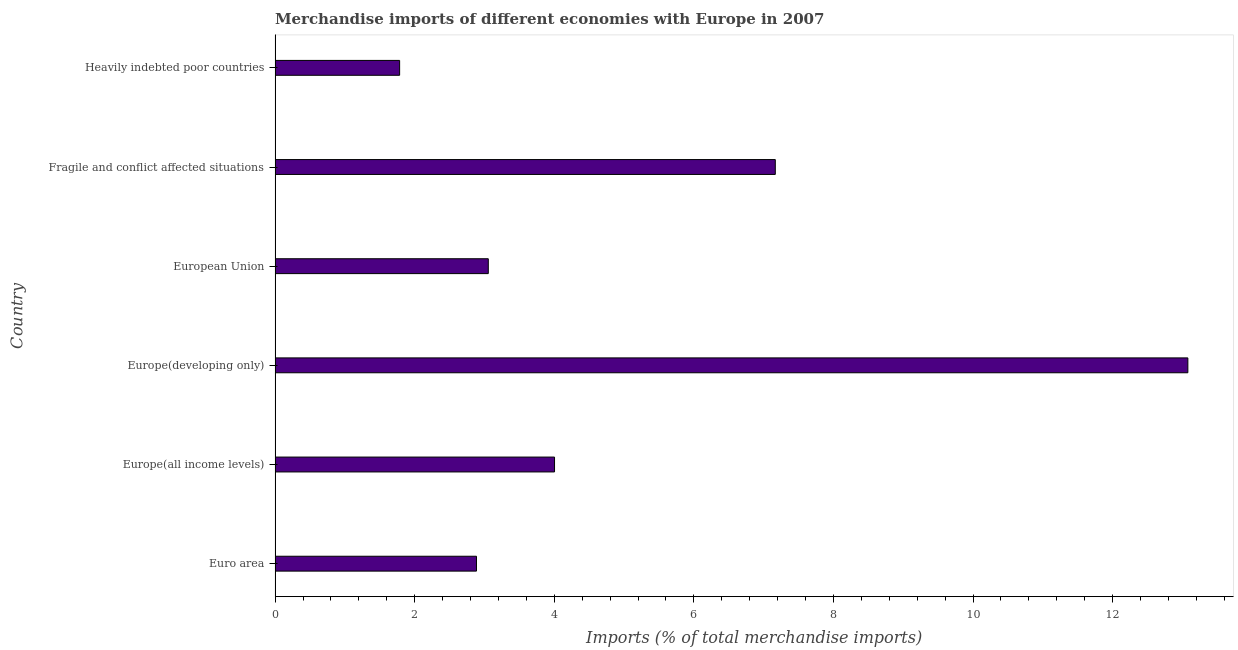Does the graph contain any zero values?
Provide a succinct answer. No. What is the title of the graph?
Offer a very short reply. Merchandise imports of different economies with Europe in 2007. What is the label or title of the X-axis?
Provide a succinct answer. Imports (% of total merchandise imports). What is the label or title of the Y-axis?
Keep it short and to the point. Country. What is the merchandise imports in Euro area?
Offer a terse response. 2.89. Across all countries, what is the maximum merchandise imports?
Keep it short and to the point. 13.08. Across all countries, what is the minimum merchandise imports?
Offer a very short reply. 1.78. In which country was the merchandise imports maximum?
Provide a succinct answer. Europe(developing only). In which country was the merchandise imports minimum?
Give a very brief answer. Heavily indebted poor countries. What is the sum of the merchandise imports?
Keep it short and to the point. 31.97. What is the difference between the merchandise imports in Europe(all income levels) and Heavily indebted poor countries?
Your answer should be compact. 2.22. What is the average merchandise imports per country?
Provide a succinct answer. 5.33. What is the median merchandise imports?
Keep it short and to the point. 3.53. In how many countries, is the merchandise imports greater than 3.6 %?
Give a very brief answer. 3. What is the ratio of the merchandise imports in Europe(all income levels) to that in Heavily indebted poor countries?
Ensure brevity in your answer.  2.24. Is the merchandise imports in Europe(all income levels) less than that in Heavily indebted poor countries?
Make the answer very short. No. Is the difference between the merchandise imports in Europe(developing only) and European Union greater than the difference between any two countries?
Your answer should be very brief. No. What is the difference between the highest and the second highest merchandise imports?
Offer a very short reply. 5.91. What is the difference between the highest and the lowest merchandise imports?
Your answer should be compact. 11.29. In how many countries, is the merchandise imports greater than the average merchandise imports taken over all countries?
Ensure brevity in your answer.  2. How many bars are there?
Offer a very short reply. 6. Are all the bars in the graph horizontal?
Provide a short and direct response. Yes. How many countries are there in the graph?
Offer a very short reply. 6. Are the values on the major ticks of X-axis written in scientific E-notation?
Your response must be concise. No. What is the Imports (% of total merchandise imports) in Euro area?
Give a very brief answer. 2.89. What is the Imports (% of total merchandise imports) of Europe(all income levels)?
Make the answer very short. 4. What is the Imports (% of total merchandise imports) in Europe(developing only)?
Your answer should be very brief. 13.08. What is the Imports (% of total merchandise imports) of European Union?
Your answer should be compact. 3.05. What is the Imports (% of total merchandise imports) in Fragile and conflict affected situations?
Provide a short and direct response. 7.17. What is the Imports (% of total merchandise imports) of Heavily indebted poor countries?
Keep it short and to the point. 1.78. What is the difference between the Imports (% of total merchandise imports) in Euro area and Europe(all income levels)?
Your answer should be compact. -1.12. What is the difference between the Imports (% of total merchandise imports) in Euro area and Europe(developing only)?
Offer a terse response. -10.19. What is the difference between the Imports (% of total merchandise imports) in Euro area and European Union?
Offer a very short reply. -0.17. What is the difference between the Imports (% of total merchandise imports) in Euro area and Fragile and conflict affected situations?
Provide a succinct answer. -4.28. What is the difference between the Imports (% of total merchandise imports) in Euro area and Heavily indebted poor countries?
Make the answer very short. 1.1. What is the difference between the Imports (% of total merchandise imports) in Europe(all income levels) and Europe(developing only)?
Your answer should be compact. -9.07. What is the difference between the Imports (% of total merchandise imports) in Europe(all income levels) and European Union?
Keep it short and to the point. 0.95. What is the difference between the Imports (% of total merchandise imports) in Europe(all income levels) and Fragile and conflict affected situations?
Keep it short and to the point. -3.16. What is the difference between the Imports (% of total merchandise imports) in Europe(all income levels) and Heavily indebted poor countries?
Ensure brevity in your answer.  2.22. What is the difference between the Imports (% of total merchandise imports) in Europe(developing only) and European Union?
Your answer should be very brief. 10.02. What is the difference between the Imports (% of total merchandise imports) in Europe(developing only) and Fragile and conflict affected situations?
Offer a very short reply. 5.91. What is the difference between the Imports (% of total merchandise imports) in Europe(developing only) and Heavily indebted poor countries?
Offer a terse response. 11.29. What is the difference between the Imports (% of total merchandise imports) in European Union and Fragile and conflict affected situations?
Provide a succinct answer. -4.11. What is the difference between the Imports (% of total merchandise imports) in European Union and Heavily indebted poor countries?
Your response must be concise. 1.27. What is the difference between the Imports (% of total merchandise imports) in Fragile and conflict affected situations and Heavily indebted poor countries?
Your answer should be compact. 5.38. What is the ratio of the Imports (% of total merchandise imports) in Euro area to that in Europe(all income levels)?
Your response must be concise. 0.72. What is the ratio of the Imports (% of total merchandise imports) in Euro area to that in Europe(developing only)?
Your response must be concise. 0.22. What is the ratio of the Imports (% of total merchandise imports) in Euro area to that in European Union?
Make the answer very short. 0.94. What is the ratio of the Imports (% of total merchandise imports) in Euro area to that in Fragile and conflict affected situations?
Your answer should be compact. 0.4. What is the ratio of the Imports (% of total merchandise imports) in Euro area to that in Heavily indebted poor countries?
Provide a short and direct response. 1.62. What is the ratio of the Imports (% of total merchandise imports) in Europe(all income levels) to that in Europe(developing only)?
Give a very brief answer. 0.31. What is the ratio of the Imports (% of total merchandise imports) in Europe(all income levels) to that in European Union?
Your response must be concise. 1.31. What is the ratio of the Imports (% of total merchandise imports) in Europe(all income levels) to that in Fragile and conflict affected situations?
Provide a short and direct response. 0.56. What is the ratio of the Imports (% of total merchandise imports) in Europe(all income levels) to that in Heavily indebted poor countries?
Keep it short and to the point. 2.24. What is the ratio of the Imports (% of total merchandise imports) in Europe(developing only) to that in European Union?
Offer a terse response. 4.28. What is the ratio of the Imports (% of total merchandise imports) in Europe(developing only) to that in Fragile and conflict affected situations?
Make the answer very short. 1.82. What is the ratio of the Imports (% of total merchandise imports) in Europe(developing only) to that in Heavily indebted poor countries?
Your response must be concise. 7.33. What is the ratio of the Imports (% of total merchandise imports) in European Union to that in Fragile and conflict affected situations?
Keep it short and to the point. 0.43. What is the ratio of the Imports (% of total merchandise imports) in European Union to that in Heavily indebted poor countries?
Offer a terse response. 1.71. What is the ratio of the Imports (% of total merchandise imports) in Fragile and conflict affected situations to that in Heavily indebted poor countries?
Keep it short and to the point. 4.02. 